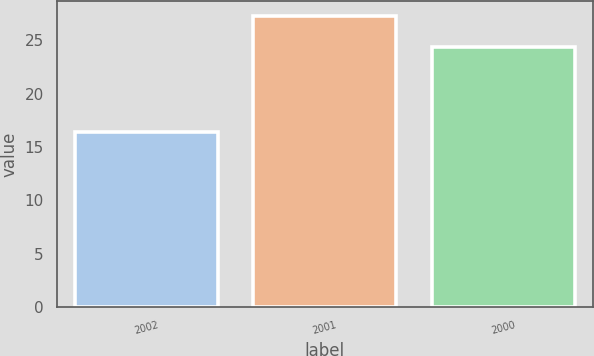<chart> <loc_0><loc_0><loc_500><loc_500><bar_chart><fcel>2002<fcel>2001<fcel>2000<nl><fcel>16.4<fcel>27.3<fcel>24.4<nl></chart> 